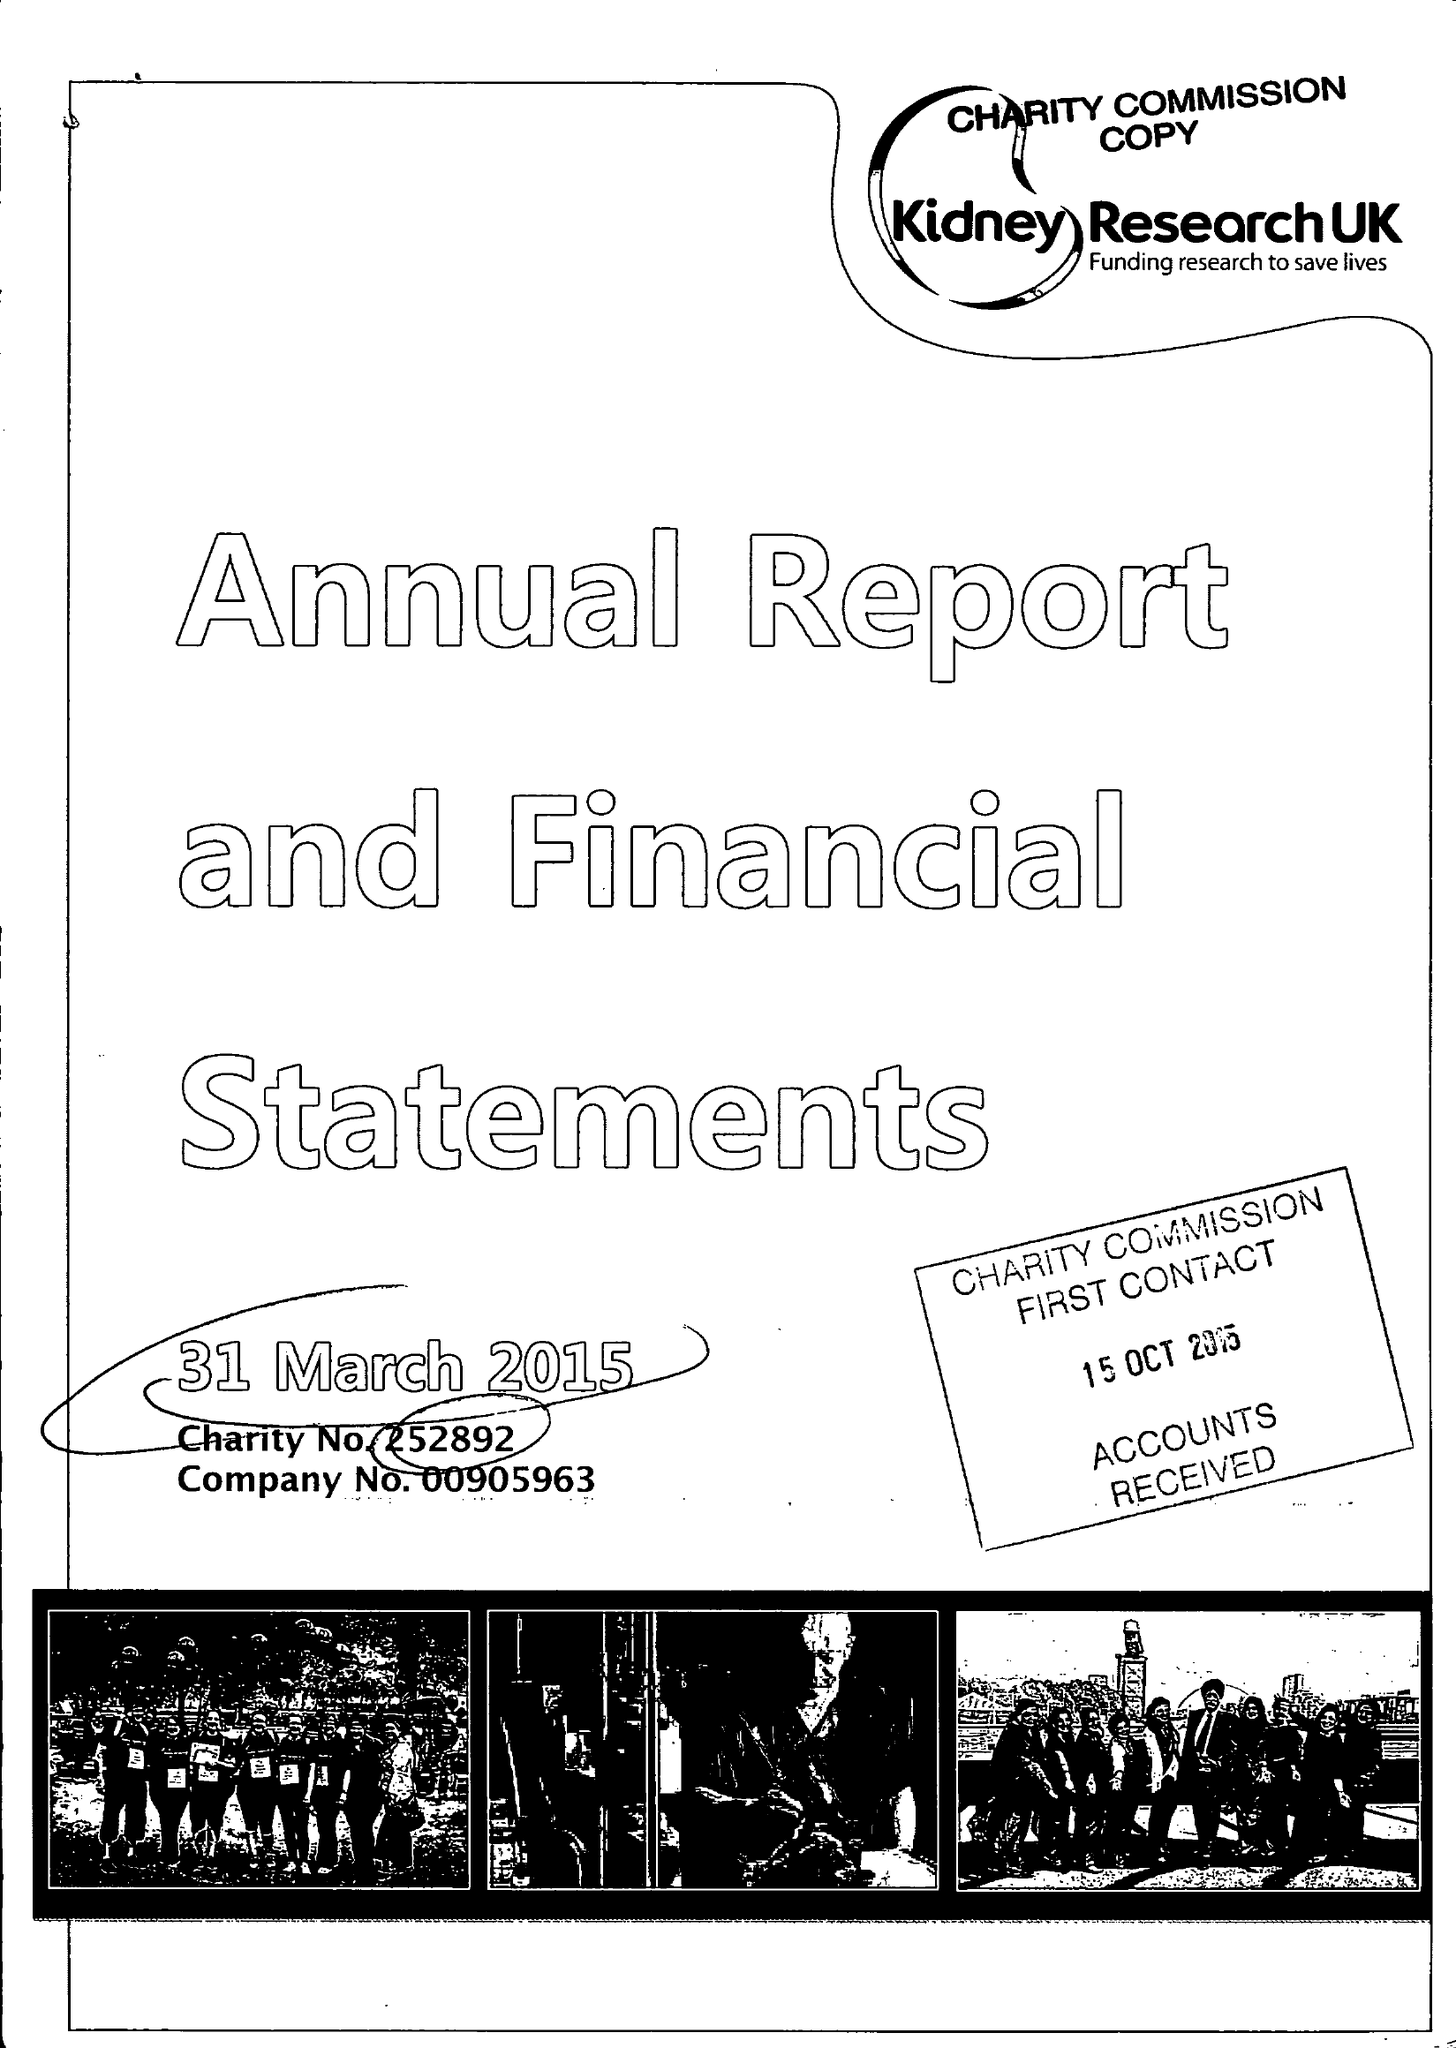What is the value for the address__postcode?
Answer the question using a single word or phrase. PE2 6FZ 